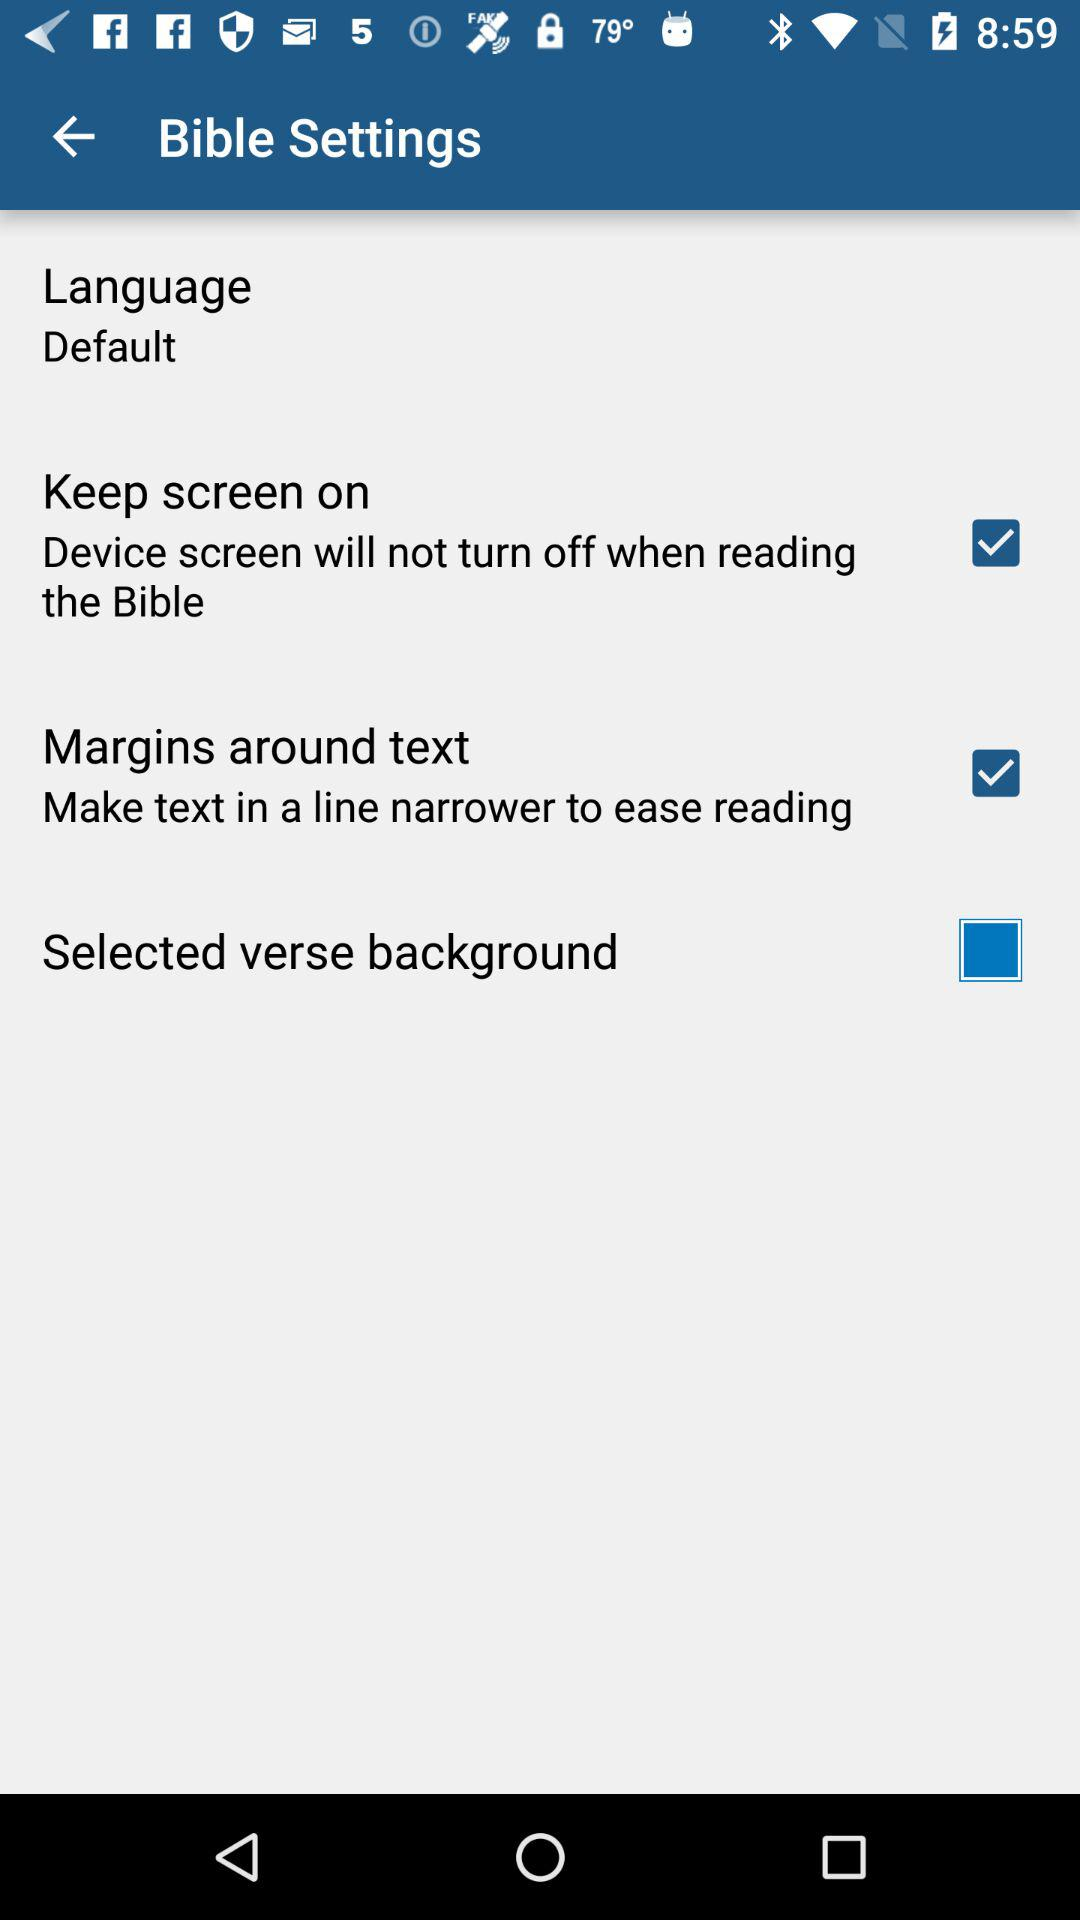What is the status of "Margins around text"? The status of "Margins around text" is "on". 